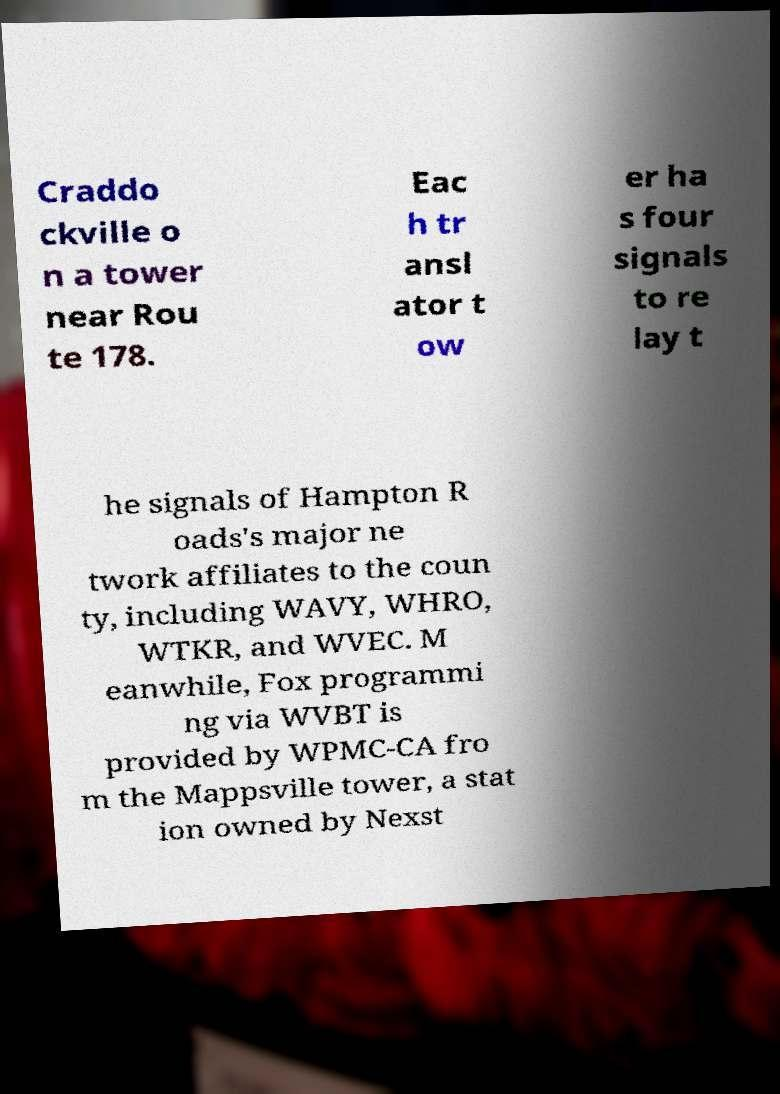What messages or text are displayed in this image? I need them in a readable, typed format. Craddo ckville o n a tower near Rou te 178. Eac h tr ansl ator t ow er ha s four signals to re lay t he signals of Hampton R oads's major ne twork affiliates to the coun ty, including WAVY, WHRO, WTKR, and WVEC. M eanwhile, Fox programmi ng via WVBT is provided by WPMC-CA fro m the Mappsville tower, a stat ion owned by Nexst 